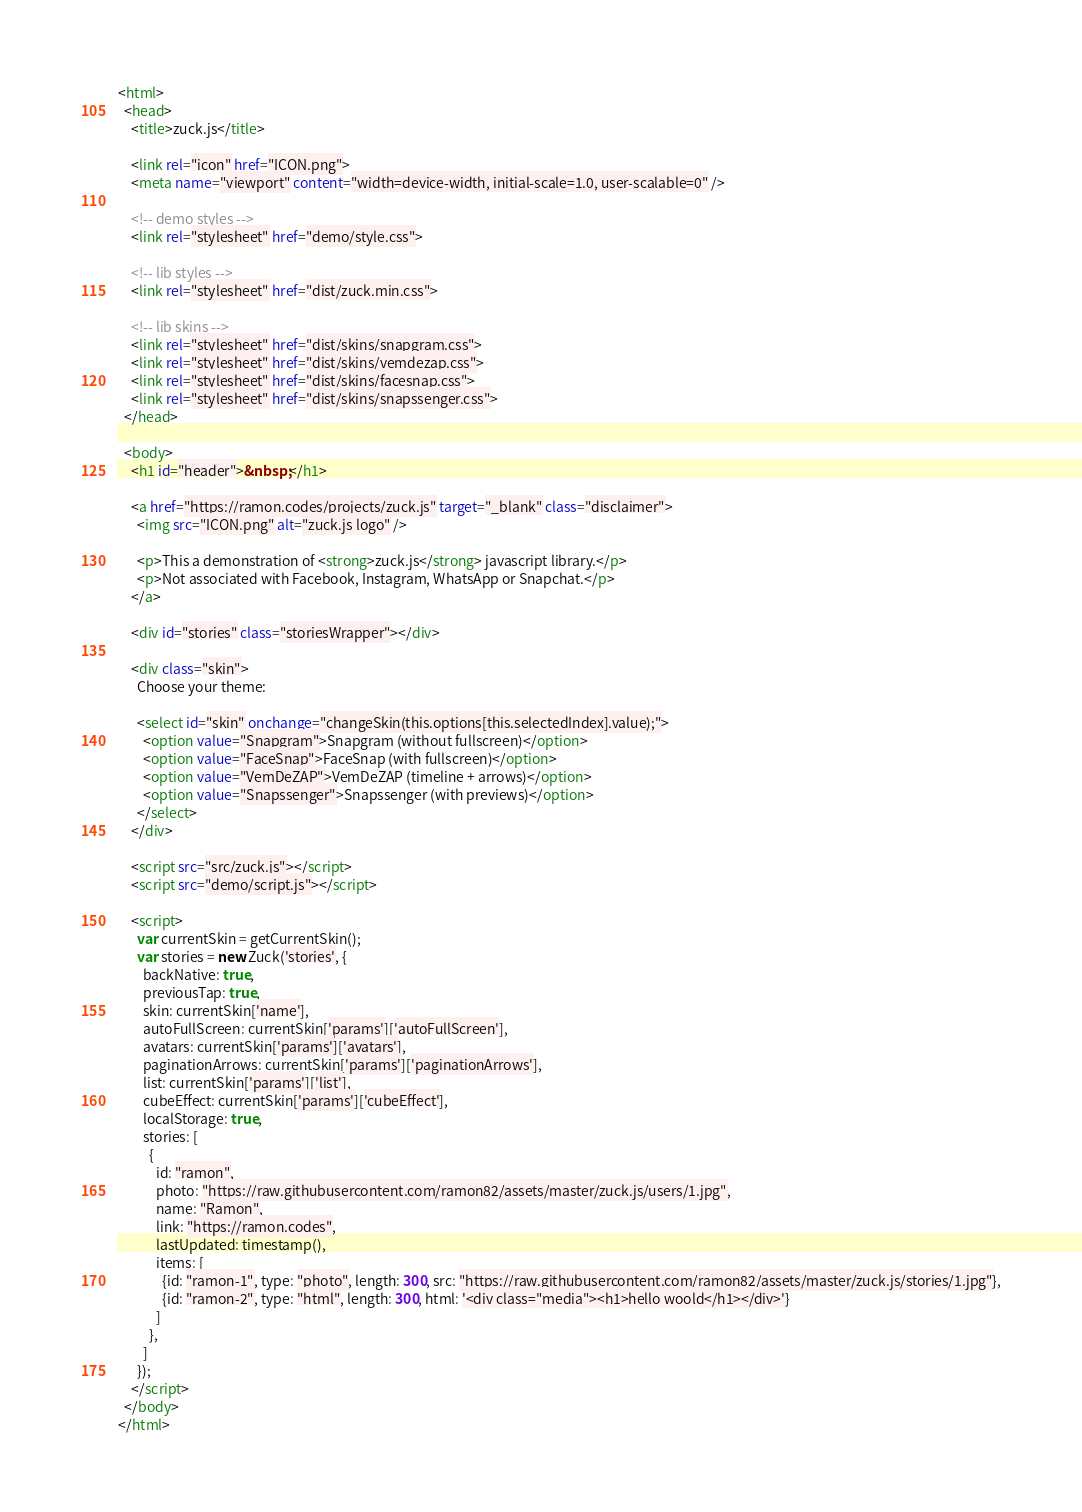<code> <loc_0><loc_0><loc_500><loc_500><_HTML_><html>
  <head>
    <title>zuck.js</title>

    <link rel="icon" href="ICON.png">
    <meta name="viewport" content="width=device-width, initial-scale=1.0, user-scalable=0" />

    <!-- demo styles -->
    <link rel="stylesheet" href="demo/style.css">

    <!-- lib styles -->
    <link rel="stylesheet" href="dist/zuck.min.css">
    
    <!-- lib skins -->
    <link rel="stylesheet" href="dist/skins/snapgram.css">
    <link rel="stylesheet" href="dist/skins/vemdezap.css">
    <link rel="stylesheet" href="dist/skins/facesnap.css">
    <link rel="stylesheet" href="dist/skins/snapssenger.css">
  </head>

  <body>
    <h1 id="header">&nbsp;</h1>

    <a href="https://ramon.codes/projects/zuck.js" target="_blank" class="disclaimer">
      <img src="ICON.png" alt="zuck.js logo" />

      <p>This a demonstration of <strong>zuck.js</strong> javascript library.</p>
      <p>Not associated with Facebook, Instagram, WhatsApp or Snapchat.</p>
    </a>

    <div id="stories" class="storiesWrapper"></div>

    <div class="skin">
      Choose your theme:

      <select id="skin" onchange="changeSkin(this.options[this.selectedIndex].value);">
        <option value="Snapgram">Snapgram (without fullscreen)</option>
        <option value="FaceSnap">FaceSnap (with fullscreen)</option>
        <option value="VemDeZAP">VemDeZAP (timeline + arrows)</option>
        <option value="Snapssenger">Snapssenger (with previews)</option>
      </select>
    </div>

    <script src="src/zuck.js"></script>
    <script src="demo/script.js"></script>

    <script>
      var currentSkin = getCurrentSkin();
      var stories = new Zuck('stories', {
        backNative: true,
        previousTap: true,
        skin: currentSkin['name'],
        autoFullScreen: currentSkin['params']['autoFullScreen'],
        avatars: currentSkin['params']['avatars'],
        paginationArrows: currentSkin['params']['paginationArrows'],
        list: currentSkin['params']['list'],
        cubeEffect: currentSkin['params']['cubeEffect'],
        localStorage: true,
        stories: [
          {
            id: "ramon", 
            photo: "https://raw.githubusercontent.com/ramon82/assets/master/zuck.js/users/1.jpg",
            name: "Ramon",
            link: "https://ramon.codes",
            lastUpdated: timestamp(),
            items: [
              {id: "ramon-1", type: "photo", length: 300, src: "https://raw.githubusercontent.com/ramon82/assets/master/zuck.js/stories/1.jpg"},
              {id: "ramon-2", type: "html", length: 300, html: '<div class="media"><h1>hello woold</h1></div>'}
            ]
          },
        ]
      });
    </script>
  </body>
</html></code> 